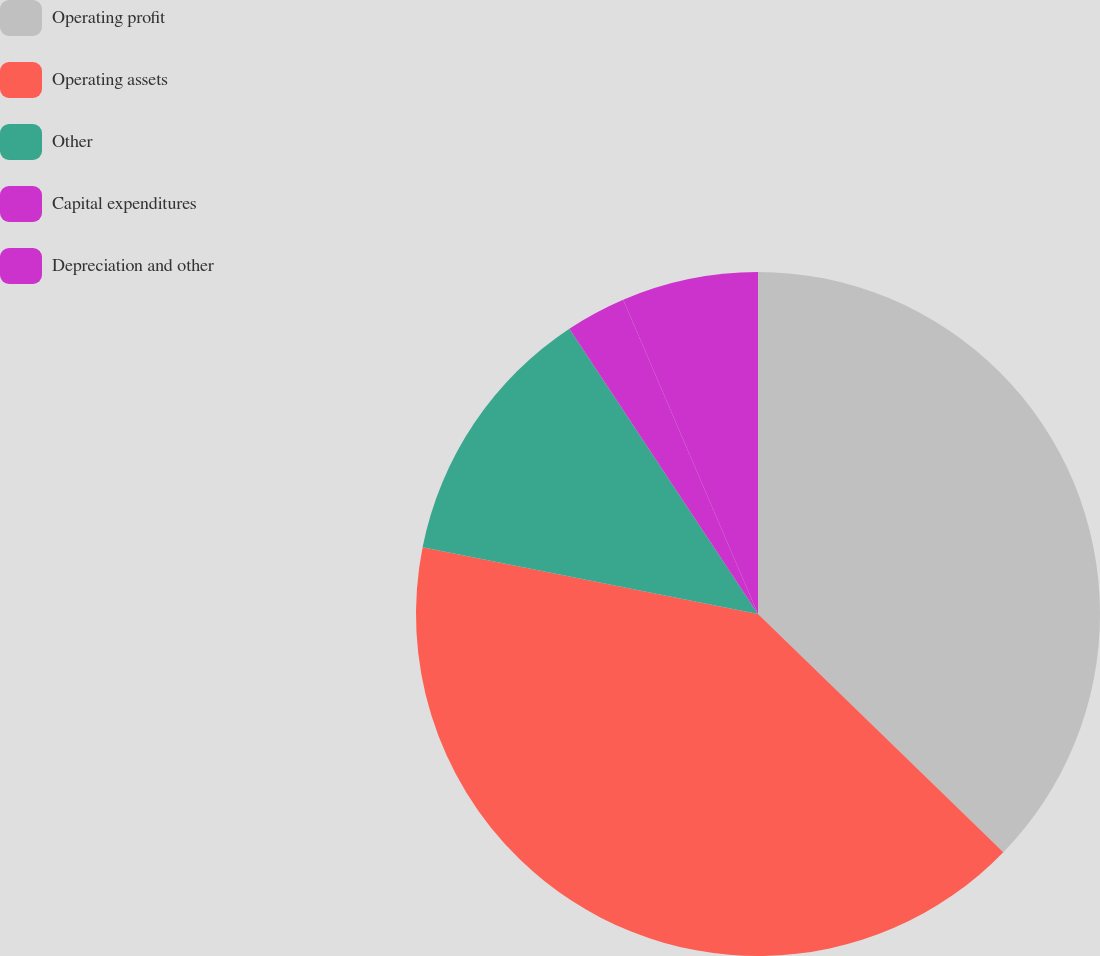Convert chart. <chart><loc_0><loc_0><loc_500><loc_500><pie_chart><fcel>Operating profit<fcel>Operating assets<fcel>Other<fcel>Capital expenditures<fcel>Depreciation and other<nl><fcel>37.27%<fcel>40.87%<fcel>12.57%<fcel>2.85%<fcel>6.45%<nl></chart> 